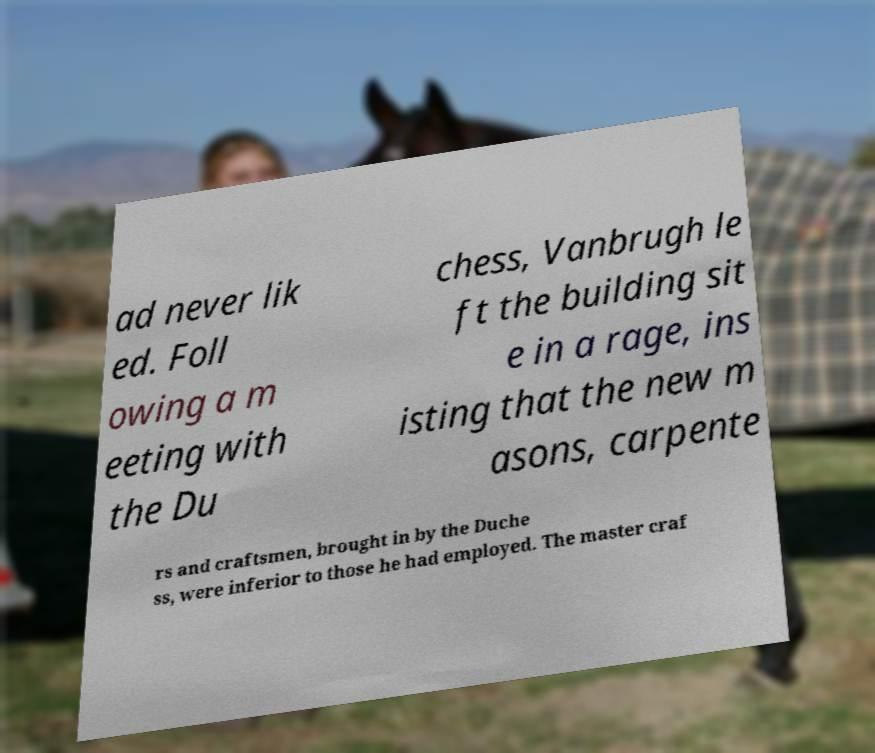What messages or text are displayed in this image? I need them in a readable, typed format. ad never lik ed. Foll owing a m eeting with the Du chess, Vanbrugh le ft the building sit e in a rage, ins isting that the new m asons, carpente rs and craftsmen, brought in by the Duche ss, were inferior to those he had employed. The master craf 